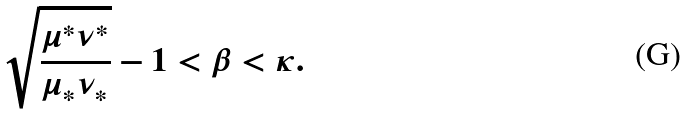Convert formula to latex. <formula><loc_0><loc_0><loc_500><loc_500>\sqrt { \frac { \mu ^ { * } \nu ^ { * } } { \mu _ { * } \nu _ { * } } } - 1 < \beta < \kappa .</formula> 